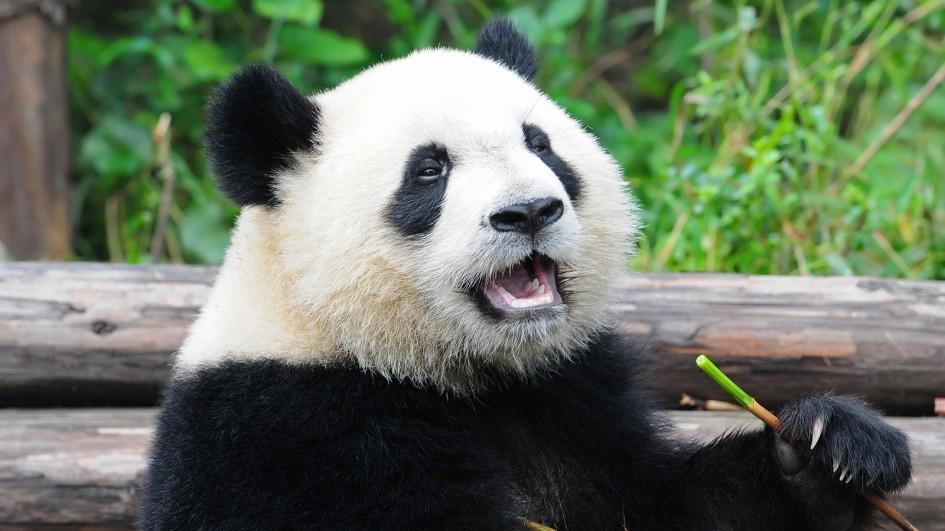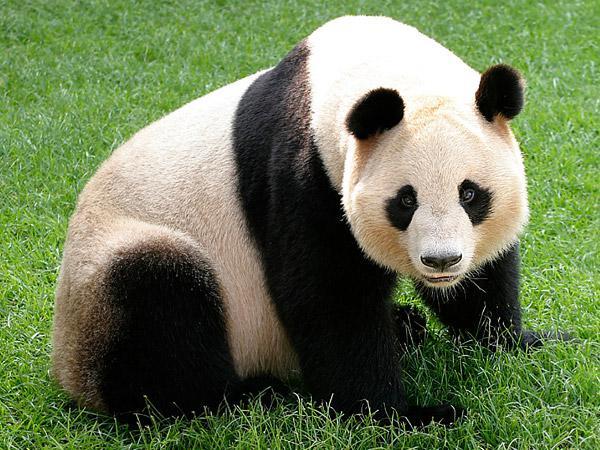The first image is the image on the left, the second image is the image on the right. Examine the images to the left and right. Is the description "The panda in the left image has a bamboo stock in their hand." accurate? Answer yes or no. Yes. The first image is the image on the left, the second image is the image on the right. For the images shown, is this caption "The lefthand image contains one panda, which is holding a green stalk." true? Answer yes or no. Yes. 